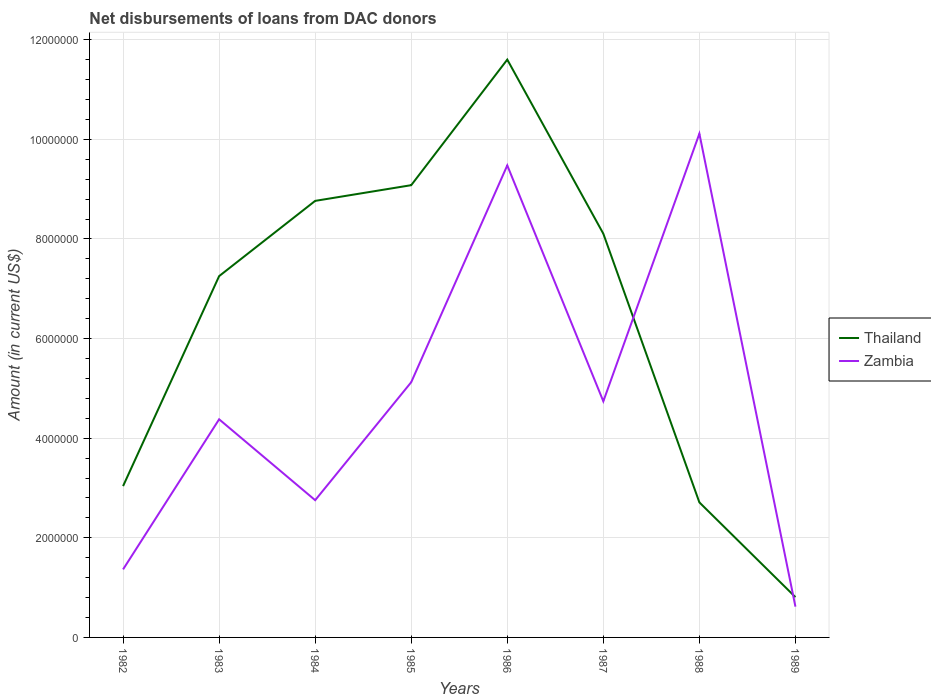How many different coloured lines are there?
Provide a succinct answer. 2. Across all years, what is the maximum amount of loans disbursed in Thailand?
Provide a short and direct response. 8.09e+05. In which year was the amount of loans disbursed in Zambia maximum?
Offer a very short reply. 1989. What is the total amount of loans disbursed in Zambia in the graph?
Your response must be concise. 3.84e+05. What is the difference between the highest and the second highest amount of loans disbursed in Zambia?
Your answer should be compact. 9.50e+06. What is the difference between the highest and the lowest amount of loans disbursed in Thailand?
Your answer should be compact. 5. Is the amount of loans disbursed in Zambia strictly greater than the amount of loans disbursed in Thailand over the years?
Provide a succinct answer. No. What is the difference between two consecutive major ticks on the Y-axis?
Ensure brevity in your answer.  2.00e+06. Does the graph contain any zero values?
Ensure brevity in your answer.  No. Does the graph contain grids?
Your response must be concise. Yes. How are the legend labels stacked?
Ensure brevity in your answer.  Vertical. What is the title of the graph?
Your answer should be very brief. Net disbursements of loans from DAC donors. Does "Saudi Arabia" appear as one of the legend labels in the graph?
Provide a succinct answer. No. What is the label or title of the X-axis?
Give a very brief answer. Years. What is the Amount (in current US$) in Thailand in 1982?
Make the answer very short. 3.04e+06. What is the Amount (in current US$) in Zambia in 1982?
Ensure brevity in your answer.  1.37e+06. What is the Amount (in current US$) of Thailand in 1983?
Ensure brevity in your answer.  7.25e+06. What is the Amount (in current US$) in Zambia in 1983?
Your answer should be very brief. 4.38e+06. What is the Amount (in current US$) of Thailand in 1984?
Give a very brief answer. 8.76e+06. What is the Amount (in current US$) in Zambia in 1984?
Your answer should be very brief. 2.76e+06. What is the Amount (in current US$) in Thailand in 1985?
Give a very brief answer. 9.08e+06. What is the Amount (in current US$) of Zambia in 1985?
Offer a very short reply. 5.12e+06. What is the Amount (in current US$) of Thailand in 1986?
Ensure brevity in your answer.  1.16e+07. What is the Amount (in current US$) of Zambia in 1986?
Offer a terse response. 9.48e+06. What is the Amount (in current US$) of Thailand in 1987?
Offer a terse response. 8.10e+06. What is the Amount (in current US$) in Zambia in 1987?
Offer a terse response. 4.74e+06. What is the Amount (in current US$) in Thailand in 1988?
Give a very brief answer. 2.71e+06. What is the Amount (in current US$) of Zambia in 1988?
Ensure brevity in your answer.  1.01e+07. What is the Amount (in current US$) in Thailand in 1989?
Your response must be concise. 8.09e+05. What is the Amount (in current US$) of Zambia in 1989?
Keep it short and to the point. 6.18e+05. Across all years, what is the maximum Amount (in current US$) of Thailand?
Provide a succinct answer. 1.16e+07. Across all years, what is the maximum Amount (in current US$) in Zambia?
Your answer should be compact. 1.01e+07. Across all years, what is the minimum Amount (in current US$) of Thailand?
Keep it short and to the point. 8.09e+05. Across all years, what is the minimum Amount (in current US$) in Zambia?
Your answer should be compact. 6.18e+05. What is the total Amount (in current US$) of Thailand in the graph?
Offer a terse response. 5.14e+07. What is the total Amount (in current US$) of Zambia in the graph?
Your answer should be very brief. 3.86e+07. What is the difference between the Amount (in current US$) in Thailand in 1982 and that in 1983?
Provide a succinct answer. -4.22e+06. What is the difference between the Amount (in current US$) in Zambia in 1982 and that in 1983?
Make the answer very short. -3.01e+06. What is the difference between the Amount (in current US$) of Thailand in 1982 and that in 1984?
Offer a very short reply. -5.73e+06. What is the difference between the Amount (in current US$) of Zambia in 1982 and that in 1984?
Provide a succinct answer. -1.39e+06. What is the difference between the Amount (in current US$) in Thailand in 1982 and that in 1985?
Offer a very short reply. -6.04e+06. What is the difference between the Amount (in current US$) of Zambia in 1982 and that in 1985?
Provide a succinct answer. -3.76e+06. What is the difference between the Amount (in current US$) in Thailand in 1982 and that in 1986?
Keep it short and to the point. -8.56e+06. What is the difference between the Amount (in current US$) of Zambia in 1982 and that in 1986?
Your response must be concise. -8.11e+06. What is the difference between the Amount (in current US$) in Thailand in 1982 and that in 1987?
Your answer should be compact. -5.07e+06. What is the difference between the Amount (in current US$) of Zambia in 1982 and that in 1987?
Make the answer very short. -3.37e+06. What is the difference between the Amount (in current US$) in Thailand in 1982 and that in 1988?
Your answer should be very brief. 3.27e+05. What is the difference between the Amount (in current US$) of Zambia in 1982 and that in 1988?
Your answer should be very brief. -8.75e+06. What is the difference between the Amount (in current US$) of Thailand in 1982 and that in 1989?
Offer a terse response. 2.23e+06. What is the difference between the Amount (in current US$) of Zambia in 1982 and that in 1989?
Provide a succinct answer. 7.48e+05. What is the difference between the Amount (in current US$) in Thailand in 1983 and that in 1984?
Your answer should be very brief. -1.51e+06. What is the difference between the Amount (in current US$) in Zambia in 1983 and that in 1984?
Ensure brevity in your answer.  1.62e+06. What is the difference between the Amount (in current US$) of Thailand in 1983 and that in 1985?
Your response must be concise. -1.83e+06. What is the difference between the Amount (in current US$) of Zambia in 1983 and that in 1985?
Keep it short and to the point. -7.45e+05. What is the difference between the Amount (in current US$) of Thailand in 1983 and that in 1986?
Offer a very short reply. -4.35e+06. What is the difference between the Amount (in current US$) of Zambia in 1983 and that in 1986?
Make the answer very short. -5.10e+06. What is the difference between the Amount (in current US$) in Thailand in 1983 and that in 1987?
Your answer should be very brief. -8.52e+05. What is the difference between the Amount (in current US$) in Zambia in 1983 and that in 1987?
Offer a very short reply. -3.61e+05. What is the difference between the Amount (in current US$) in Thailand in 1983 and that in 1988?
Keep it short and to the point. 4.54e+06. What is the difference between the Amount (in current US$) in Zambia in 1983 and that in 1988?
Provide a succinct answer. -5.73e+06. What is the difference between the Amount (in current US$) in Thailand in 1983 and that in 1989?
Provide a succinct answer. 6.44e+06. What is the difference between the Amount (in current US$) of Zambia in 1983 and that in 1989?
Your answer should be compact. 3.76e+06. What is the difference between the Amount (in current US$) in Thailand in 1984 and that in 1985?
Your answer should be compact. -3.15e+05. What is the difference between the Amount (in current US$) of Zambia in 1984 and that in 1985?
Keep it short and to the point. -2.37e+06. What is the difference between the Amount (in current US$) in Thailand in 1984 and that in 1986?
Keep it short and to the point. -2.84e+06. What is the difference between the Amount (in current US$) in Zambia in 1984 and that in 1986?
Provide a short and direct response. -6.72e+06. What is the difference between the Amount (in current US$) of Thailand in 1984 and that in 1987?
Offer a terse response. 6.59e+05. What is the difference between the Amount (in current US$) of Zambia in 1984 and that in 1987?
Your response must be concise. -1.98e+06. What is the difference between the Amount (in current US$) of Thailand in 1984 and that in 1988?
Offer a very short reply. 6.05e+06. What is the difference between the Amount (in current US$) in Zambia in 1984 and that in 1988?
Provide a short and direct response. -7.36e+06. What is the difference between the Amount (in current US$) in Thailand in 1984 and that in 1989?
Ensure brevity in your answer.  7.96e+06. What is the difference between the Amount (in current US$) of Zambia in 1984 and that in 1989?
Provide a succinct answer. 2.14e+06. What is the difference between the Amount (in current US$) in Thailand in 1985 and that in 1986?
Keep it short and to the point. -2.52e+06. What is the difference between the Amount (in current US$) of Zambia in 1985 and that in 1986?
Provide a short and direct response. -4.35e+06. What is the difference between the Amount (in current US$) in Thailand in 1985 and that in 1987?
Provide a succinct answer. 9.74e+05. What is the difference between the Amount (in current US$) of Zambia in 1985 and that in 1987?
Offer a terse response. 3.84e+05. What is the difference between the Amount (in current US$) in Thailand in 1985 and that in 1988?
Your response must be concise. 6.37e+06. What is the difference between the Amount (in current US$) of Zambia in 1985 and that in 1988?
Your answer should be very brief. -4.99e+06. What is the difference between the Amount (in current US$) in Thailand in 1985 and that in 1989?
Offer a very short reply. 8.27e+06. What is the difference between the Amount (in current US$) of Zambia in 1985 and that in 1989?
Your answer should be compact. 4.51e+06. What is the difference between the Amount (in current US$) in Thailand in 1986 and that in 1987?
Ensure brevity in your answer.  3.50e+06. What is the difference between the Amount (in current US$) of Zambia in 1986 and that in 1987?
Your response must be concise. 4.74e+06. What is the difference between the Amount (in current US$) in Thailand in 1986 and that in 1988?
Your answer should be very brief. 8.89e+06. What is the difference between the Amount (in current US$) in Zambia in 1986 and that in 1988?
Your response must be concise. -6.37e+05. What is the difference between the Amount (in current US$) of Thailand in 1986 and that in 1989?
Offer a very short reply. 1.08e+07. What is the difference between the Amount (in current US$) of Zambia in 1986 and that in 1989?
Your response must be concise. 8.86e+06. What is the difference between the Amount (in current US$) in Thailand in 1987 and that in 1988?
Give a very brief answer. 5.39e+06. What is the difference between the Amount (in current US$) in Zambia in 1987 and that in 1988?
Make the answer very short. -5.37e+06. What is the difference between the Amount (in current US$) of Thailand in 1987 and that in 1989?
Your answer should be very brief. 7.30e+06. What is the difference between the Amount (in current US$) in Zambia in 1987 and that in 1989?
Your answer should be compact. 4.12e+06. What is the difference between the Amount (in current US$) in Thailand in 1988 and that in 1989?
Ensure brevity in your answer.  1.90e+06. What is the difference between the Amount (in current US$) in Zambia in 1988 and that in 1989?
Your response must be concise. 9.50e+06. What is the difference between the Amount (in current US$) of Thailand in 1982 and the Amount (in current US$) of Zambia in 1983?
Your response must be concise. -1.34e+06. What is the difference between the Amount (in current US$) of Thailand in 1982 and the Amount (in current US$) of Zambia in 1984?
Offer a terse response. 2.83e+05. What is the difference between the Amount (in current US$) in Thailand in 1982 and the Amount (in current US$) in Zambia in 1985?
Give a very brief answer. -2.09e+06. What is the difference between the Amount (in current US$) in Thailand in 1982 and the Amount (in current US$) in Zambia in 1986?
Your response must be concise. -6.44e+06. What is the difference between the Amount (in current US$) of Thailand in 1982 and the Amount (in current US$) of Zambia in 1987?
Offer a very short reply. -1.70e+06. What is the difference between the Amount (in current US$) of Thailand in 1982 and the Amount (in current US$) of Zambia in 1988?
Give a very brief answer. -7.08e+06. What is the difference between the Amount (in current US$) of Thailand in 1982 and the Amount (in current US$) of Zambia in 1989?
Offer a terse response. 2.42e+06. What is the difference between the Amount (in current US$) of Thailand in 1983 and the Amount (in current US$) of Zambia in 1984?
Your response must be concise. 4.50e+06. What is the difference between the Amount (in current US$) in Thailand in 1983 and the Amount (in current US$) in Zambia in 1985?
Offer a very short reply. 2.13e+06. What is the difference between the Amount (in current US$) in Thailand in 1983 and the Amount (in current US$) in Zambia in 1986?
Make the answer very short. -2.22e+06. What is the difference between the Amount (in current US$) of Thailand in 1983 and the Amount (in current US$) of Zambia in 1987?
Offer a very short reply. 2.51e+06. What is the difference between the Amount (in current US$) of Thailand in 1983 and the Amount (in current US$) of Zambia in 1988?
Your answer should be very brief. -2.86e+06. What is the difference between the Amount (in current US$) in Thailand in 1983 and the Amount (in current US$) in Zambia in 1989?
Provide a succinct answer. 6.64e+06. What is the difference between the Amount (in current US$) in Thailand in 1984 and the Amount (in current US$) in Zambia in 1985?
Your response must be concise. 3.64e+06. What is the difference between the Amount (in current US$) of Thailand in 1984 and the Amount (in current US$) of Zambia in 1986?
Offer a terse response. -7.12e+05. What is the difference between the Amount (in current US$) in Thailand in 1984 and the Amount (in current US$) in Zambia in 1987?
Provide a short and direct response. 4.02e+06. What is the difference between the Amount (in current US$) in Thailand in 1984 and the Amount (in current US$) in Zambia in 1988?
Provide a short and direct response. -1.35e+06. What is the difference between the Amount (in current US$) in Thailand in 1984 and the Amount (in current US$) in Zambia in 1989?
Your answer should be compact. 8.15e+06. What is the difference between the Amount (in current US$) of Thailand in 1985 and the Amount (in current US$) of Zambia in 1986?
Offer a terse response. -3.97e+05. What is the difference between the Amount (in current US$) of Thailand in 1985 and the Amount (in current US$) of Zambia in 1987?
Provide a succinct answer. 4.34e+06. What is the difference between the Amount (in current US$) of Thailand in 1985 and the Amount (in current US$) of Zambia in 1988?
Give a very brief answer. -1.03e+06. What is the difference between the Amount (in current US$) of Thailand in 1985 and the Amount (in current US$) of Zambia in 1989?
Your answer should be compact. 8.46e+06. What is the difference between the Amount (in current US$) of Thailand in 1986 and the Amount (in current US$) of Zambia in 1987?
Your answer should be very brief. 6.86e+06. What is the difference between the Amount (in current US$) of Thailand in 1986 and the Amount (in current US$) of Zambia in 1988?
Your response must be concise. 1.49e+06. What is the difference between the Amount (in current US$) in Thailand in 1986 and the Amount (in current US$) in Zambia in 1989?
Keep it short and to the point. 1.10e+07. What is the difference between the Amount (in current US$) in Thailand in 1987 and the Amount (in current US$) in Zambia in 1988?
Provide a succinct answer. -2.01e+06. What is the difference between the Amount (in current US$) of Thailand in 1987 and the Amount (in current US$) of Zambia in 1989?
Ensure brevity in your answer.  7.49e+06. What is the difference between the Amount (in current US$) in Thailand in 1988 and the Amount (in current US$) in Zambia in 1989?
Ensure brevity in your answer.  2.09e+06. What is the average Amount (in current US$) in Thailand per year?
Keep it short and to the point. 6.42e+06. What is the average Amount (in current US$) of Zambia per year?
Provide a succinct answer. 4.82e+06. In the year 1982, what is the difference between the Amount (in current US$) in Thailand and Amount (in current US$) in Zambia?
Keep it short and to the point. 1.67e+06. In the year 1983, what is the difference between the Amount (in current US$) of Thailand and Amount (in current US$) of Zambia?
Your response must be concise. 2.87e+06. In the year 1984, what is the difference between the Amount (in current US$) in Thailand and Amount (in current US$) in Zambia?
Offer a very short reply. 6.01e+06. In the year 1985, what is the difference between the Amount (in current US$) in Thailand and Amount (in current US$) in Zambia?
Keep it short and to the point. 3.96e+06. In the year 1986, what is the difference between the Amount (in current US$) of Thailand and Amount (in current US$) of Zambia?
Your answer should be very brief. 2.12e+06. In the year 1987, what is the difference between the Amount (in current US$) in Thailand and Amount (in current US$) in Zambia?
Your response must be concise. 3.36e+06. In the year 1988, what is the difference between the Amount (in current US$) of Thailand and Amount (in current US$) of Zambia?
Make the answer very short. -7.40e+06. In the year 1989, what is the difference between the Amount (in current US$) of Thailand and Amount (in current US$) of Zambia?
Offer a very short reply. 1.91e+05. What is the ratio of the Amount (in current US$) of Thailand in 1982 to that in 1983?
Your answer should be compact. 0.42. What is the ratio of the Amount (in current US$) in Zambia in 1982 to that in 1983?
Your answer should be very brief. 0.31. What is the ratio of the Amount (in current US$) in Thailand in 1982 to that in 1984?
Offer a terse response. 0.35. What is the ratio of the Amount (in current US$) in Zambia in 1982 to that in 1984?
Provide a succinct answer. 0.5. What is the ratio of the Amount (in current US$) in Thailand in 1982 to that in 1985?
Offer a very short reply. 0.33. What is the ratio of the Amount (in current US$) of Zambia in 1982 to that in 1985?
Offer a terse response. 0.27. What is the ratio of the Amount (in current US$) in Thailand in 1982 to that in 1986?
Your response must be concise. 0.26. What is the ratio of the Amount (in current US$) of Zambia in 1982 to that in 1986?
Your answer should be very brief. 0.14. What is the ratio of the Amount (in current US$) of Thailand in 1982 to that in 1987?
Make the answer very short. 0.37. What is the ratio of the Amount (in current US$) in Zambia in 1982 to that in 1987?
Provide a succinct answer. 0.29. What is the ratio of the Amount (in current US$) of Thailand in 1982 to that in 1988?
Make the answer very short. 1.12. What is the ratio of the Amount (in current US$) in Zambia in 1982 to that in 1988?
Offer a terse response. 0.14. What is the ratio of the Amount (in current US$) of Thailand in 1982 to that in 1989?
Ensure brevity in your answer.  3.76. What is the ratio of the Amount (in current US$) of Zambia in 1982 to that in 1989?
Your response must be concise. 2.21. What is the ratio of the Amount (in current US$) in Thailand in 1983 to that in 1984?
Your answer should be compact. 0.83. What is the ratio of the Amount (in current US$) of Zambia in 1983 to that in 1984?
Make the answer very short. 1.59. What is the ratio of the Amount (in current US$) of Thailand in 1983 to that in 1985?
Offer a very short reply. 0.8. What is the ratio of the Amount (in current US$) of Zambia in 1983 to that in 1985?
Your answer should be compact. 0.85. What is the ratio of the Amount (in current US$) of Thailand in 1983 to that in 1986?
Offer a very short reply. 0.63. What is the ratio of the Amount (in current US$) of Zambia in 1983 to that in 1986?
Your response must be concise. 0.46. What is the ratio of the Amount (in current US$) in Thailand in 1983 to that in 1987?
Make the answer very short. 0.89. What is the ratio of the Amount (in current US$) of Zambia in 1983 to that in 1987?
Your answer should be very brief. 0.92. What is the ratio of the Amount (in current US$) in Thailand in 1983 to that in 1988?
Offer a very short reply. 2.68. What is the ratio of the Amount (in current US$) of Zambia in 1983 to that in 1988?
Give a very brief answer. 0.43. What is the ratio of the Amount (in current US$) of Thailand in 1983 to that in 1989?
Give a very brief answer. 8.97. What is the ratio of the Amount (in current US$) of Zambia in 1983 to that in 1989?
Offer a very short reply. 7.09. What is the ratio of the Amount (in current US$) of Thailand in 1984 to that in 1985?
Give a very brief answer. 0.97. What is the ratio of the Amount (in current US$) of Zambia in 1984 to that in 1985?
Provide a short and direct response. 0.54. What is the ratio of the Amount (in current US$) in Thailand in 1984 to that in 1986?
Make the answer very short. 0.76. What is the ratio of the Amount (in current US$) of Zambia in 1984 to that in 1986?
Your answer should be very brief. 0.29. What is the ratio of the Amount (in current US$) in Thailand in 1984 to that in 1987?
Provide a succinct answer. 1.08. What is the ratio of the Amount (in current US$) of Zambia in 1984 to that in 1987?
Ensure brevity in your answer.  0.58. What is the ratio of the Amount (in current US$) in Thailand in 1984 to that in 1988?
Give a very brief answer. 3.23. What is the ratio of the Amount (in current US$) in Zambia in 1984 to that in 1988?
Offer a very short reply. 0.27. What is the ratio of the Amount (in current US$) in Thailand in 1984 to that in 1989?
Make the answer very short. 10.83. What is the ratio of the Amount (in current US$) of Zambia in 1984 to that in 1989?
Provide a short and direct response. 4.46. What is the ratio of the Amount (in current US$) in Thailand in 1985 to that in 1986?
Offer a very short reply. 0.78. What is the ratio of the Amount (in current US$) of Zambia in 1985 to that in 1986?
Offer a very short reply. 0.54. What is the ratio of the Amount (in current US$) in Thailand in 1985 to that in 1987?
Give a very brief answer. 1.12. What is the ratio of the Amount (in current US$) in Zambia in 1985 to that in 1987?
Give a very brief answer. 1.08. What is the ratio of the Amount (in current US$) in Thailand in 1985 to that in 1988?
Provide a succinct answer. 3.35. What is the ratio of the Amount (in current US$) of Zambia in 1985 to that in 1988?
Ensure brevity in your answer.  0.51. What is the ratio of the Amount (in current US$) in Thailand in 1985 to that in 1989?
Make the answer very short. 11.22. What is the ratio of the Amount (in current US$) in Zambia in 1985 to that in 1989?
Give a very brief answer. 8.29. What is the ratio of the Amount (in current US$) of Thailand in 1986 to that in 1987?
Give a very brief answer. 1.43. What is the ratio of the Amount (in current US$) of Zambia in 1986 to that in 1987?
Provide a succinct answer. 2. What is the ratio of the Amount (in current US$) in Thailand in 1986 to that in 1988?
Your answer should be very brief. 4.28. What is the ratio of the Amount (in current US$) in Zambia in 1986 to that in 1988?
Give a very brief answer. 0.94. What is the ratio of the Amount (in current US$) in Thailand in 1986 to that in 1989?
Provide a short and direct response. 14.34. What is the ratio of the Amount (in current US$) in Zambia in 1986 to that in 1989?
Ensure brevity in your answer.  15.33. What is the ratio of the Amount (in current US$) in Thailand in 1987 to that in 1988?
Your answer should be very brief. 2.99. What is the ratio of the Amount (in current US$) in Zambia in 1987 to that in 1988?
Provide a short and direct response. 0.47. What is the ratio of the Amount (in current US$) of Thailand in 1987 to that in 1989?
Provide a short and direct response. 10.02. What is the ratio of the Amount (in current US$) of Zambia in 1987 to that in 1989?
Your answer should be very brief. 7.67. What is the ratio of the Amount (in current US$) of Thailand in 1988 to that in 1989?
Offer a terse response. 3.35. What is the ratio of the Amount (in current US$) in Zambia in 1988 to that in 1989?
Provide a succinct answer. 16.36. What is the difference between the highest and the second highest Amount (in current US$) in Thailand?
Give a very brief answer. 2.52e+06. What is the difference between the highest and the second highest Amount (in current US$) in Zambia?
Provide a succinct answer. 6.37e+05. What is the difference between the highest and the lowest Amount (in current US$) in Thailand?
Make the answer very short. 1.08e+07. What is the difference between the highest and the lowest Amount (in current US$) of Zambia?
Give a very brief answer. 9.50e+06. 